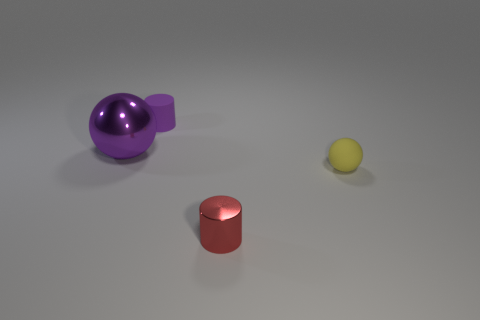Add 3 cyan shiny blocks. How many cyan shiny blocks exist? 3 Add 4 shiny cylinders. How many objects exist? 8 Subtract all purple cylinders. How many cylinders are left? 1 Subtract 0 red balls. How many objects are left? 4 Subtract 2 cylinders. How many cylinders are left? 0 Subtract all blue balls. Subtract all purple blocks. How many balls are left? 2 Subtract all brown blocks. How many brown cylinders are left? 0 Subtract all small red balls. Subtract all red cylinders. How many objects are left? 3 Add 3 yellow rubber balls. How many yellow rubber balls are left? 4 